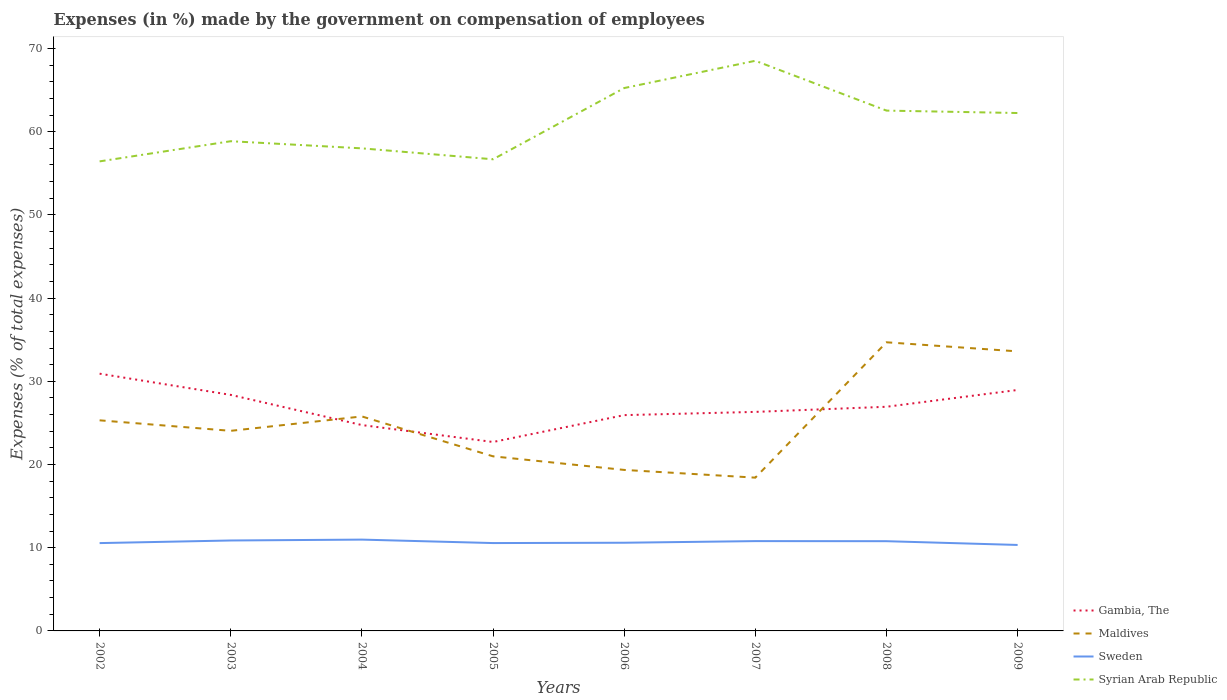Across all years, what is the maximum percentage of expenses made by the government on compensation of employees in Gambia, The?
Your answer should be compact. 22.71. What is the total percentage of expenses made by the government on compensation of employees in Sweden in the graph?
Provide a succinct answer. 0.27. What is the difference between the highest and the second highest percentage of expenses made by the government on compensation of employees in Gambia, The?
Your answer should be compact. 8.21. Is the percentage of expenses made by the government on compensation of employees in Gambia, The strictly greater than the percentage of expenses made by the government on compensation of employees in Maldives over the years?
Make the answer very short. No. How many years are there in the graph?
Give a very brief answer. 8. What is the difference between two consecutive major ticks on the Y-axis?
Your response must be concise. 10. Does the graph contain any zero values?
Keep it short and to the point. No. Does the graph contain grids?
Offer a very short reply. No. Where does the legend appear in the graph?
Your answer should be very brief. Bottom right. What is the title of the graph?
Provide a short and direct response. Expenses (in %) made by the government on compensation of employees. Does "Moldova" appear as one of the legend labels in the graph?
Offer a terse response. No. What is the label or title of the Y-axis?
Keep it short and to the point. Expenses (% of total expenses). What is the Expenses (% of total expenses) of Gambia, The in 2002?
Keep it short and to the point. 30.92. What is the Expenses (% of total expenses) in Maldives in 2002?
Keep it short and to the point. 25.31. What is the Expenses (% of total expenses) in Sweden in 2002?
Ensure brevity in your answer.  10.56. What is the Expenses (% of total expenses) of Syrian Arab Republic in 2002?
Ensure brevity in your answer.  56.43. What is the Expenses (% of total expenses) in Gambia, The in 2003?
Provide a succinct answer. 28.37. What is the Expenses (% of total expenses) in Maldives in 2003?
Make the answer very short. 24.05. What is the Expenses (% of total expenses) of Sweden in 2003?
Offer a very short reply. 10.87. What is the Expenses (% of total expenses) of Syrian Arab Republic in 2003?
Your answer should be very brief. 58.86. What is the Expenses (% of total expenses) in Gambia, The in 2004?
Provide a succinct answer. 24.74. What is the Expenses (% of total expenses) in Maldives in 2004?
Your response must be concise. 25.78. What is the Expenses (% of total expenses) of Sweden in 2004?
Offer a terse response. 10.97. What is the Expenses (% of total expenses) in Syrian Arab Republic in 2004?
Make the answer very short. 58. What is the Expenses (% of total expenses) of Gambia, The in 2005?
Provide a succinct answer. 22.71. What is the Expenses (% of total expenses) of Maldives in 2005?
Provide a succinct answer. 20.98. What is the Expenses (% of total expenses) in Sweden in 2005?
Ensure brevity in your answer.  10.56. What is the Expenses (% of total expenses) of Syrian Arab Republic in 2005?
Provide a succinct answer. 56.68. What is the Expenses (% of total expenses) of Gambia, The in 2006?
Offer a terse response. 25.94. What is the Expenses (% of total expenses) of Maldives in 2006?
Provide a succinct answer. 19.35. What is the Expenses (% of total expenses) of Sweden in 2006?
Your response must be concise. 10.6. What is the Expenses (% of total expenses) in Syrian Arab Republic in 2006?
Your answer should be compact. 65.25. What is the Expenses (% of total expenses) in Gambia, The in 2007?
Give a very brief answer. 26.32. What is the Expenses (% of total expenses) in Maldives in 2007?
Your answer should be compact. 18.42. What is the Expenses (% of total expenses) of Sweden in 2007?
Provide a short and direct response. 10.79. What is the Expenses (% of total expenses) of Syrian Arab Republic in 2007?
Your response must be concise. 68.52. What is the Expenses (% of total expenses) in Gambia, The in 2008?
Offer a very short reply. 26.94. What is the Expenses (% of total expenses) in Maldives in 2008?
Your answer should be compact. 34.69. What is the Expenses (% of total expenses) of Sweden in 2008?
Give a very brief answer. 10.78. What is the Expenses (% of total expenses) in Syrian Arab Republic in 2008?
Give a very brief answer. 62.53. What is the Expenses (% of total expenses) in Gambia, The in 2009?
Make the answer very short. 28.96. What is the Expenses (% of total expenses) of Maldives in 2009?
Give a very brief answer. 33.6. What is the Expenses (% of total expenses) of Sweden in 2009?
Your answer should be very brief. 10.33. What is the Expenses (% of total expenses) of Syrian Arab Republic in 2009?
Ensure brevity in your answer.  62.24. Across all years, what is the maximum Expenses (% of total expenses) in Gambia, The?
Offer a very short reply. 30.92. Across all years, what is the maximum Expenses (% of total expenses) of Maldives?
Provide a succinct answer. 34.69. Across all years, what is the maximum Expenses (% of total expenses) of Sweden?
Offer a terse response. 10.97. Across all years, what is the maximum Expenses (% of total expenses) of Syrian Arab Republic?
Offer a terse response. 68.52. Across all years, what is the minimum Expenses (% of total expenses) of Gambia, The?
Keep it short and to the point. 22.71. Across all years, what is the minimum Expenses (% of total expenses) of Maldives?
Provide a short and direct response. 18.42. Across all years, what is the minimum Expenses (% of total expenses) in Sweden?
Ensure brevity in your answer.  10.33. Across all years, what is the minimum Expenses (% of total expenses) in Syrian Arab Republic?
Keep it short and to the point. 56.43. What is the total Expenses (% of total expenses) in Gambia, The in the graph?
Offer a terse response. 214.89. What is the total Expenses (% of total expenses) in Maldives in the graph?
Ensure brevity in your answer.  202.18. What is the total Expenses (% of total expenses) in Sweden in the graph?
Your answer should be compact. 85.47. What is the total Expenses (% of total expenses) of Syrian Arab Republic in the graph?
Provide a short and direct response. 488.51. What is the difference between the Expenses (% of total expenses) in Gambia, The in 2002 and that in 2003?
Offer a terse response. 2.55. What is the difference between the Expenses (% of total expenses) in Maldives in 2002 and that in 2003?
Give a very brief answer. 1.26. What is the difference between the Expenses (% of total expenses) in Sweden in 2002 and that in 2003?
Provide a succinct answer. -0.31. What is the difference between the Expenses (% of total expenses) of Syrian Arab Republic in 2002 and that in 2003?
Provide a succinct answer. -2.42. What is the difference between the Expenses (% of total expenses) in Gambia, The in 2002 and that in 2004?
Offer a very short reply. 6.18. What is the difference between the Expenses (% of total expenses) of Maldives in 2002 and that in 2004?
Offer a very short reply. -0.47. What is the difference between the Expenses (% of total expenses) in Sweden in 2002 and that in 2004?
Offer a very short reply. -0.42. What is the difference between the Expenses (% of total expenses) in Syrian Arab Republic in 2002 and that in 2004?
Keep it short and to the point. -1.57. What is the difference between the Expenses (% of total expenses) in Gambia, The in 2002 and that in 2005?
Provide a short and direct response. 8.21. What is the difference between the Expenses (% of total expenses) of Maldives in 2002 and that in 2005?
Provide a succinct answer. 4.33. What is the difference between the Expenses (% of total expenses) in Sweden in 2002 and that in 2005?
Keep it short and to the point. -0. What is the difference between the Expenses (% of total expenses) in Syrian Arab Republic in 2002 and that in 2005?
Keep it short and to the point. -0.25. What is the difference between the Expenses (% of total expenses) in Gambia, The in 2002 and that in 2006?
Keep it short and to the point. 4.98. What is the difference between the Expenses (% of total expenses) in Maldives in 2002 and that in 2006?
Give a very brief answer. 5.96. What is the difference between the Expenses (% of total expenses) in Sweden in 2002 and that in 2006?
Your answer should be very brief. -0.04. What is the difference between the Expenses (% of total expenses) of Syrian Arab Republic in 2002 and that in 2006?
Give a very brief answer. -8.81. What is the difference between the Expenses (% of total expenses) of Gambia, The in 2002 and that in 2007?
Give a very brief answer. 4.59. What is the difference between the Expenses (% of total expenses) of Maldives in 2002 and that in 2007?
Your answer should be compact. 6.89. What is the difference between the Expenses (% of total expenses) in Sweden in 2002 and that in 2007?
Your answer should be compact. -0.24. What is the difference between the Expenses (% of total expenses) in Syrian Arab Republic in 2002 and that in 2007?
Ensure brevity in your answer.  -12.09. What is the difference between the Expenses (% of total expenses) in Gambia, The in 2002 and that in 2008?
Your answer should be compact. 3.98. What is the difference between the Expenses (% of total expenses) in Maldives in 2002 and that in 2008?
Your answer should be very brief. -9.38. What is the difference between the Expenses (% of total expenses) of Sweden in 2002 and that in 2008?
Your answer should be very brief. -0.23. What is the difference between the Expenses (% of total expenses) in Syrian Arab Republic in 2002 and that in 2008?
Provide a succinct answer. -6.1. What is the difference between the Expenses (% of total expenses) of Gambia, The in 2002 and that in 2009?
Provide a succinct answer. 1.96. What is the difference between the Expenses (% of total expenses) in Maldives in 2002 and that in 2009?
Your answer should be very brief. -8.29. What is the difference between the Expenses (% of total expenses) of Sweden in 2002 and that in 2009?
Provide a succinct answer. 0.22. What is the difference between the Expenses (% of total expenses) of Syrian Arab Republic in 2002 and that in 2009?
Keep it short and to the point. -5.81. What is the difference between the Expenses (% of total expenses) in Gambia, The in 2003 and that in 2004?
Make the answer very short. 3.63. What is the difference between the Expenses (% of total expenses) of Maldives in 2003 and that in 2004?
Provide a succinct answer. -1.73. What is the difference between the Expenses (% of total expenses) in Sweden in 2003 and that in 2004?
Give a very brief answer. -0.1. What is the difference between the Expenses (% of total expenses) of Syrian Arab Republic in 2003 and that in 2004?
Give a very brief answer. 0.86. What is the difference between the Expenses (% of total expenses) in Gambia, The in 2003 and that in 2005?
Your answer should be very brief. 5.66. What is the difference between the Expenses (% of total expenses) in Maldives in 2003 and that in 2005?
Give a very brief answer. 3.07. What is the difference between the Expenses (% of total expenses) in Sweden in 2003 and that in 2005?
Offer a very short reply. 0.31. What is the difference between the Expenses (% of total expenses) in Syrian Arab Republic in 2003 and that in 2005?
Your response must be concise. 2.17. What is the difference between the Expenses (% of total expenses) of Gambia, The in 2003 and that in 2006?
Your answer should be very brief. 2.43. What is the difference between the Expenses (% of total expenses) of Maldives in 2003 and that in 2006?
Your answer should be compact. 4.7. What is the difference between the Expenses (% of total expenses) of Sweden in 2003 and that in 2006?
Your response must be concise. 0.27. What is the difference between the Expenses (% of total expenses) of Syrian Arab Republic in 2003 and that in 2006?
Ensure brevity in your answer.  -6.39. What is the difference between the Expenses (% of total expenses) in Gambia, The in 2003 and that in 2007?
Make the answer very short. 2.04. What is the difference between the Expenses (% of total expenses) in Maldives in 2003 and that in 2007?
Your answer should be compact. 5.63. What is the difference between the Expenses (% of total expenses) of Sweden in 2003 and that in 2007?
Your answer should be compact. 0.08. What is the difference between the Expenses (% of total expenses) of Syrian Arab Republic in 2003 and that in 2007?
Your answer should be very brief. -9.67. What is the difference between the Expenses (% of total expenses) of Gambia, The in 2003 and that in 2008?
Make the answer very short. 1.43. What is the difference between the Expenses (% of total expenses) in Maldives in 2003 and that in 2008?
Your answer should be very brief. -10.64. What is the difference between the Expenses (% of total expenses) of Sweden in 2003 and that in 2008?
Your response must be concise. 0.09. What is the difference between the Expenses (% of total expenses) of Syrian Arab Republic in 2003 and that in 2008?
Your answer should be compact. -3.68. What is the difference between the Expenses (% of total expenses) in Gambia, The in 2003 and that in 2009?
Your answer should be very brief. -0.59. What is the difference between the Expenses (% of total expenses) of Maldives in 2003 and that in 2009?
Offer a terse response. -9.55. What is the difference between the Expenses (% of total expenses) in Sweden in 2003 and that in 2009?
Your answer should be very brief. 0.54. What is the difference between the Expenses (% of total expenses) of Syrian Arab Republic in 2003 and that in 2009?
Keep it short and to the point. -3.39. What is the difference between the Expenses (% of total expenses) in Gambia, The in 2004 and that in 2005?
Keep it short and to the point. 2.03. What is the difference between the Expenses (% of total expenses) in Maldives in 2004 and that in 2005?
Offer a very short reply. 4.79. What is the difference between the Expenses (% of total expenses) of Sweden in 2004 and that in 2005?
Offer a terse response. 0.42. What is the difference between the Expenses (% of total expenses) in Syrian Arab Republic in 2004 and that in 2005?
Your answer should be very brief. 1.31. What is the difference between the Expenses (% of total expenses) of Gambia, The in 2004 and that in 2006?
Keep it short and to the point. -1.19. What is the difference between the Expenses (% of total expenses) of Maldives in 2004 and that in 2006?
Keep it short and to the point. 6.43. What is the difference between the Expenses (% of total expenses) of Sweden in 2004 and that in 2006?
Your answer should be very brief. 0.38. What is the difference between the Expenses (% of total expenses) of Syrian Arab Republic in 2004 and that in 2006?
Your answer should be very brief. -7.25. What is the difference between the Expenses (% of total expenses) in Gambia, The in 2004 and that in 2007?
Keep it short and to the point. -1.58. What is the difference between the Expenses (% of total expenses) of Maldives in 2004 and that in 2007?
Offer a terse response. 7.36. What is the difference between the Expenses (% of total expenses) of Sweden in 2004 and that in 2007?
Offer a terse response. 0.18. What is the difference between the Expenses (% of total expenses) of Syrian Arab Republic in 2004 and that in 2007?
Give a very brief answer. -10.52. What is the difference between the Expenses (% of total expenses) in Gambia, The in 2004 and that in 2008?
Your answer should be very brief. -2.2. What is the difference between the Expenses (% of total expenses) in Maldives in 2004 and that in 2008?
Provide a succinct answer. -8.91. What is the difference between the Expenses (% of total expenses) in Sweden in 2004 and that in 2008?
Your response must be concise. 0.19. What is the difference between the Expenses (% of total expenses) in Syrian Arab Republic in 2004 and that in 2008?
Give a very brief answer. -4.54. What is the difference between the Expenses (% of total expenses) in Gambia, The in 2004 and that in 2009?
Provide a succinct answer. -4.22. What is the difference between the Expenses (% of total expenses) of Maldives in 2004 and that in 2009?
Your answer should be very brief. -7.82. What is the difference between the Expenses (% of total expenses) in Sweden in 2004 and that in 2009?
Your answer should be compact. 0.64. What is the difference between the Expenses (% of total expenses) in Syrian Arab Republic in 2004 and that in 2009?
Keep it short and to the point. -4.25. What is the difference between the Expenses (% of total expenses) in Gambia, The in 2005 and that in 2006?
Provide a succinct answer. -3.23. What is the difference between the Expenses (% of total expenses) in Maldives in 2005 and that in 2006?
Your answer should be very brief. 1.63. What is the difference between the Expenses (% of total expenses) in Sweden in 2005 and that in 2006?
Provide a short and direct response. -0.04. What is the difference between the Expenses (% of total expenses) in Syrian Arab Republic in 2005 and that in 2006?
Give a very brief answer. -8.56. What is the difference between the Expenses (% of total expenses) of Gambia, The in 2005 and that in 2007?
Ensure brevity in your answer.  -3.62. What is the difference between the Expenses (% of total expenses) of Maldives in 2005 and that in 2007?
Make the answer very short. 2.56. What is the difference between the Expenses (% of total expenses) of Sweden in 2005 and that in 2007?
Offer a very short reply. -0.23. What is the difference between the Expenses (% of total expenses) of Syrian Arab Republic in 2005 and that in 2007?
Make the answer very short. -11.84. What is the difference between the Expenses (% of total expenses) of Gambia, The in 2005 and that in 2008?
Provide a short and direct response. -4.23. What is the difference between the Expenses (% of total expenses) in Maldives in 2005 and that in 2008?
Give a very brief answer. -13.71. What is the difference between the Expenses (% of total expenses) in Sweden in 2005 and that in 2008?
Your answer should be very brief. -0.22. What is the difference between the Expenses (% of total expenses) in Syrian Arab Republic in 2005 and that in 2008?
Your answer should be very brief. -5.85. What is the difference between the Expenses (% of total expenses) of Gambia, The in 2005 and that in 2009?
Keep it short and to the point. -6.25. What is the difference between the Expenses (% of total expenses) in Maldives in 2005 and that in 2009?
Provide a succinct answer. -12.61. What is the difference between the Expenses (% of total expenses) in Sweden in 2005 and that in 2009?
Offer a terse response. 0.23. What is the difference between the Expenses (% of total expenses) in Syrian Arab Republic in 2005 and that in 2009?
Your response must be concise. -5.56. What is the difference between the Expenses (% of total expenses) in Gambia, The in 2006 and that in 2007?
Give a very brief answer. -0.39. What is the difference between the Expenses (% of total expenses) of Maldives in 2006 and that in 2007?
Give a very brief answer. 0.93. What is the difference between the Expenses (% of total expenses) of Sweden in 2006 and that in 2007?
Offer a terse response. -0.2. What is the difference between the Expenses (% of total expenses) of Syrian Arab Republic in 2006 and that in 2007?
Keep it short and to the point. -3.28. What is the difference between the Expenses (% of total expenses) in Gambia, The in 2006 and that in 2008?
Ensure brevity in your answer.  -1. What is the difference between the Expenses (% of total expenses) of Maldives in 2006 and that in 2008?
Your answer should be very brief. -15.34. What is the difference between the Expenses (% of total expenses) of Sweden in 2006 and that in 2008?
Give a very brief answer. -0.19. What is the difference between the Expenses (% of total expenses) of Syrian Arab Republic in 2006 and that in 2008?
Your answer should be compact. 2.71. What is the difference between the Expenses (% of total expenses) in Gambia, The in 2006 and that in 2009?
Your response must be concise. -3.02. What is the difference between the Expenses (% of total expenses) of Maldives in 2006 and that in 2009?
Your answer should be very brief. -14.25. What is the difference between the Expenses (% of total expenses) of Sweden in 2006 and that in 2009?
Give a very brief answer. 0.27. What is the difference between the Expenses (% of total expenses) of Syrian Arab Republic in 2006 and that in 2009?
Make the answer very short. 3. What is the difference between the Expenses (% of total expenses) of Gambia, The in 2007 and that in 2008?
Make the answer very short. -0.62. What is the difference between the Expenses (% of total expenses) in Maldives in 2007 and that in 2008?
Ensure brevity in your answer.  -16.27. What is the difference between the Expenses (% of total expenses) of Sweden in 2007 and that in 2008?
Your response must be concise. 0.01. What is the difference between the Expenses (% of total expenses) of Syrian Arab Republic in 2007 and that in 2008?
Give a very brief answer. 5.99. What is the difference between the Expenses (% of total expenses) in Gambia, The in 2007 and that in 2009?
Offer a terse response. -2.63. What is the difference between the Expenses (% of total expenses) of Maldives in 2007 and that in 2009?
Provide a short and direct response. -15.18. What is the difference between the Expenses (% of total expenses) of Sweden in 2007 and that in 2009?
Ensure brevity in your answer.  0.46. What is the difference between the Expenses (% of total expenses) of Syrian Arab Republic in 2007 and that in 2009?
Your answer should be compact. 6.28. What is the difference between the Expenses (% of total expenses) in Gambia, The in 2008 and that in 2009?
Your answer should be compact. -2.02. What is the difference between the Expenses (% of total expenses) of Maldives in 2008 and that in 2009?
Provide a short and direct response. 1.09. What is the difference between the Expenses (% of total expenses) of Sweden in 2008 and that in 2009?
Ensure brevity in your answer.  0.45. What is the difference between the Expenses (% of total expenses) of Syrian Arab Republic in 2008 and that in 2009?
Make the answer very short. 0.29. What is the difference between the Expenses (% of total expenses) of Gambia, The in 2002 and the Expenses (% of total expenses) of Maldives in 2003?
Keep it short and to the point. 6.87. What is the difference between the Expenses (% of total expenses) of Gambia, The in 2002 and the Expenses (% of total expenses) of Sweden in 2003?
Make the answer very short. 20.05. What is the difference between the Expenses (% of total expenses) in Gambia, The in 2002 and the Expenses (% of total expenses) in Syrian Arab Republic in 2003?
Keep it short and to the point. -27.94. What is the difference between the Expenses (% of total expenses) in Maldives in 2002 and the Expenses (% of total expenses) in Sweden in 2003?
Your answer should be compact. 14.44. What is the difference between the Expenses (% of total expenses) of Maldives in 2002 and the Expenses (% of total expenses) of Syrian Arab Republic in 2003?
Your answer should be very brief. -33.55. What is the difference between the Expenses (% of total expenses) in Sweden in 2002 and the Expenses (% of total expenses) in Syrian Arab Republic in 2003?
Provide a succinct answer. -48.3. What is the difference between the Expenses (% of total expenses) in Gambia, The in 2002 and the Expenses (% of total expenses) in Maldives in 2004?
Give a very brief answer. 5.14. What is the difference between the Expenses (% of total expenses) of Gambia, The in 2002 and the Expenses (% of total expenses) of Sweden in 2004?
Your response must be concise. 19.94. What is the difference between the Expenses (% of total expenses) of Gambia, The in 2002 and the Expenses (% of total expenses) of Syrian Arab Republic in 2004?
Keep it short and to the point. -27.08. What is the difference between the Expenses (% of total expenses) in Maldives in 2002 and the Expenses (% of total expenses) in Sweden in 2004?
Offer a very short reply. 14.34. What is the difference between the Expenses (% of total expenses) in Maldives in 2002 and the Expenses (% of total expenses) in Syrian Arab Republic in 2004?
Your response must be concise. -32.69. What is the difference between the Expenses (% of total expenses) of Sweden in 2002 and the Expenses (% of total expenses) of Syrian Arab Republic in 2004?
Ensure brevity in your answer.  -47.44. What is the difference between the Expenses (% of total expenses) in Gambia, The in 2002 and the Expenses (% of total expenses) in Maldives in 2005?
Provide a succinct answer. 9.93. What is the difference between the Expenses (% of total expenses) of Gambia, The in 2002 and the Expenses (% of total expenses) of Sweden in 2005?
Offer a terse response. 20.36. What is the difference between the Expenses (% of total expenses) in Gambia, The in 2002 and the Expenses (% of total expenses) in Syrian Arab Republic in 2005?
Provide a succinct answer. -25.77. What is the difference between the Expenses (% of total expenses) of Maldives in 2002 and the Expenses (% of total expenses) of Sweden in 2005?
Ensure brevity in your answer.  14.75. What is the difference between the Expenses (% of total expenses) in Maldives in 2002 and the Expenses (% of total expenses) in Syrian Arab Republic in 2005?
Offer a terse response. -31.37. What is the difference between the Expenses (% of total expenses) of Sweden in 2002 and the Expenses (% of total expenses) of Syrian Arab Republic in 2005?
Keep it short and to the point. -46.13. What is the difference between the Expenses (% of total expenses) in Gambia, The in 2002 and the Expenses (% of total expenses) in Maldives in 2006?
Your answer should be compact. 11.57. What is the difference between the Expenses (% of total expenses) of Gambia, The in 2002 and the Expenses (% of total expenses) of Sweden in 2006?
Ensure brevity in your answer.  20.32. What is the difference between the Expenses (% of total expenses) in Gambia, The in 2002 and the Expenses (% of total expenses) in Syrian Arab Republic in 2006?
Provide a succinct answer. -34.33. What is the difference between the Expenses (% of total expenses) in Maldives in 2002 and the Expenses (% of total expenses) in Sweden in 2006?
Your answer should be compact. 14.71. What is the difference between the Expenses (% of total expenses) in Maldives in 2002 and the Expenses (% of total expenses) in Syrian Arab Republic in 2006?
Provide a short and direct response. -39.93. What is the difference between the Expenses (% of total expenses) of Sweden in 2002 and the Expenses (% of total expenses) of Syrian Arab Republic in 2006?
Offer a very short reply. -54.69. What is the difference between the Expenses (% of total expenses) of Gambia, The in 2002 and the Expenses (% of total expenses) of Maldives in 2007?
Provide a short and direct response. 12.49. What is the difference between the Expenses (% of total expenses) of Gambia, The in 2002 and the Expenses (% of total expenses) of Sweden in 2007?
Make the answer very short. 20.12. What is the difference between the Expenses (% of total expenses) of Gambia, The in 2002 and the Expenses (% of total expenses) of Syrian Arab Republic in 2007?
Provide a succinct answer. -37.61. What is the difference between the Expenses (% of total expenses) in Maldives in 2002 and the Expenses (% of total expenses) in Sweden in 2007?
Give a very brief answer. 14.52. What is the difference between the Expenses (% of total expenses) of Maldives in 2002 and the Expenses (% of total expenses) of Syrian Arab Republic in 2007?
Provide a succinct answer. -43.21. What is the difference between the Expenses (% of total expenses) of Sweden in 2002 and the Expenses (% of total expenses) of Syrian Arab Republic in 2007?
Provide a short and direct response. -57.97. What is the difference between the Expenses (% of total expenses) of Gambia, The in 2002 and the Expenses (% of total expenses) of Maldives in 2008?
Keep it short and to the point. -3.77. What is the difference between the Expenses (% of total expenses) in Gambia, The in 2002 and the Expenses (% of total expenses) in Sweden in 2008?
Make the answer very short. 20.13. What is the difference between the Expenses (% of total expenses) of Gambia, The in 2002 and the Expenses (% of total expenses) of Syrian Arab Republic in 2008?
Ensure brevity in your answer.  -31.62. What is the difference between the Expenses (% of total expenses) of Maldives in 2002 and the Expenses (% of total expenses) of Sweden in 2008?
Ensure brevity in your answer.  14.53. What is the difference between the Expenses (% of total expenses) of Maldives in 2002 and the Expenses (% of total expenses) of Syrian Arab Republic in 2008?
Your answer should be very brief. -37.22. What is the difference between the Expenses (% of total expenses) of Sweden in 2002 and the Expenses (% of total expenses) of Syrian Arab Republic in 2008?
Your answer should be compact. -51.98. What is the difference between the Expenses (% of total expenses) in Gambia, The in 2002 and the Expenses (% of total expenses) in Maldives in 2009?
Provide a succinct answer. -2.68. What is the difference between the Expenses (% of total expenses) in Gambia, The in 2002 and the Expenses (% of total expenses) in Sweden in 2009?
Provide a short and direct response. 20.58. What is the difference between the Expenses (% of total expenses) of Gambia, The in 2002 and the Expenses (% of total expenses) of Syrian Arab Republic in 2009?
Provide a short and direct response. -31.33. What is the difference between the Expenses (% of total expenses) in Maldives in 2002 and the Expenses (% of total expenses) in Sweden in 2009?
Keep it short and to the point. 14.98. What is the difference between the Expenses (% of total expenses) in Maldives in 2002 and the Expenses (% of total expenses) in Syrian Arab Republic in 2009?
Your response must be concise. -36.93. What is the difference between the Expenses (% of total expenses) in Sweden in 2002 and the Expenses (% of total expenses) in Syrian Arab Republic in 2009?
Ensure brevity in your answer.  -51.69. What is the difference between the Expenses (% of total expenses) of Gambia, The in 2003 and the Expenses (% of total expenses) of Maldives in 2004?
Your answer should be compact. 2.59. What is the difference between the Expenses (% of total expenses) of Gambia, The in 2003 and the Expenses (% of total expenses) of Sweden in 2004?
Keep it short and to the point. 17.39. What is the difference between the Expenses (% of total expenses) of Gambia, The in 2003 and the Expenses (% of total expenses) of Syrian Arab Republic in 2004?
Your answer should be very brief. -29.63. What is the difference between the Expenses (% of total expenses) in Maldives in 2003 and the Expenses (% of total expenses) in Sweden in 2004?
Make the answer very short. 13.07. What is the difference between the Expenses (% of total expenses) in Maldives in 2003 and the Expenses (% of total expenses) in Syrian Arab Republic in 2004?
Your answer should be very brief. -33.95. What is the difference between the Expenses (% of total expenses) of Sweden in 2003 and the Expenses (% of total expenses) of Syrian Arab Republic in 2004?
Your answer should be compact. -47.13. What is the difference between the Expenses (% of total expenses) of Gambia, The in 2003 and the Expenses (% of total expenses) of Maldives in 2005?
Offer a very short reply. 7.38. What is the difference between the Expenses (% of total expenses) in Gambia, The in 2003 and the Expenses (% of total expenses) in Sweden in 2005?
Give a very brief answer. 17.81. What is the difference between the Expenses (% of total expenses) of Gambia, The in 2003 and the Expenses (% of total expenses) of Syrian Arab Republic in 2005?
Make the answer very short. -28.32. What is the difference between the Expenses (% of total expenses) in Maldives in 2003 and the Expenses (% of total expenses) in Sweden in 2005?
Give a very brief answer. 13.49. What is the difference between the Expenses (% of total expenses) of Maldives in 2003 and the Expenses (% of total expenses) of Syrian Arab Republic in 2005?
Offer a very short reply. -32.64. What is the difference between the Expenses (% of total expenses) of Sweden in 2003 and the Expenses (% of total expenses) of Syrian Arab Republic in 2005?
Offer a very short reply. -45.81. What is the difference between the Expenses (% of total expenses) in Gambia, The in 2003 and the Expenses (% of total expenses) in Maldives in 2006?
Keep it short and to the point. 9.02. What is the difference between the Expenses (% of total expenses) in Gambia, The in 2003 and the Expenses (% of total expenses) in Sweden in 2006?
Your answer should be compact. 17.77. What is the difference between the Expenses (% of total expenses) of Gambia, The in 2003 and the Expenses (% of total expenses) of Syrian Arab Republic in 2006?
Your answer should be very brief. -36.88. What is the difference between the Expenses (% of total expenses) of Maldives in 2003 and the Expenses (% of total expenses) of Sweden in 2006?
Keep it short and to the point. 13.45. What is the difference between the Expenses (% of total expenses) in Maldives in 2003 and the Expenses (% of total expenses) in Syrian Arab Republic in 2006?
Give a very brief answer. -41.2. What is the difference between the Expenses (% of total expenses) of Sweden in 2003 and the Expenses (% of total expenses) of Syrian Arab Republic in 2006?
Provide a succinct answer. -54.38. What is the difference between the Expenses (% of total expenses) of Gambia, The in 2003 and the Expenses (% of total expenses) of Maldives in 2007?
Give a very brief answer. 9.94. What is the difference between the Expenses (% of total expenses) of Gambia, The in 2003 and the Expenses (% of total expenses) of Sweden in 2007?
Make the answer very short. 17.57. What is the difference between the Expenses (% of total expenses) of Gambia, The in 2003 and the Expenses (% of total expenses) of Syrian Arab Republic in 2007?
Offer a terse response. -40.16. What is the difference between the Expenses (% of total expenses) in Maldives in 2003 and the Expenses (% of total expenses) in Sweden in 2007?
Ensure brevity in your answer.  13.25. What is the difference between the Expenses (% of total expenses) in Maldives in 2003 and the Expenses (% of total expenses) in Syrian Arab Republic in 2007?
Offer a very short reply. -44.47. What is the difference between the Expenses (% of total expenses) in Sweden in 2003 and the Expenses (% of total expenses) in Syrian Arab Republic in 2007?
Make the answer very short. -57.65. What is the difference between the Expenses (% of total expenses) of Gambia, The in 2003 and the Expenses (% of total expenses) of Maldives in 2008?
Ensure brevity in your answer.  -6.32. What is the difference between the Expenses (% of total expenses) in Gambia, The in 2003 and the Expenses (% of total expenses) in Sweden in 2008?
Make the answer very short. 17.58. What is the difference between the Expenses (% of total expenses) of Gambia, The in 2003 and the Expenses (% of total expenses) of Syrian Arab Republic in 2008?
Provide a short and direct response. -34.17. What is the difference between the Expenses (% of total expenses) of Maldives in 2003 and the Expenses (% of total expenses) of Sweden in 2008?
Give a very brief answer. 13.26. What is the difference between the Expenses (% of total expenses) of Maldives in 2003 and the Expenses (% of total expenses) of Syrian Arab Republic in 2008?
Provide a short and direct response. -38.49. What is the difference between the Expenses (% of total expenses) in Sweden in 2003 and the Expenses (% of total expenses) in Syrian Arab Republic in 2008?
Offer a terse response. -51.66. What is the difference between the Expenses (% of total expenses) in Gambia, The in 2003 and the Expenses (% of total expenses) in Maldives in 2009?
Offer a terse response. -5.23. What is the difference between the Expenses (% of total expenses) of Gambia, The in 2003 and the Expenses (% of total expenses) of Sweden in 2009?
Make the answer very short. 18.03. What is the difference between the Expenses (% of total expenses) in Gambia, The in 2003 and the Expenses (% of total expenses) in Syrian Arab Republic in 2009?
Your answer should be very brief. -33.88. What is the difference between the Expenses (% of total expenses) of Maldives in 2003 and the Expenses (% of total expenses) of Sweden in 2009?
Make the answer very short. 13.72. What is the difference between the Expenses (% of total expenses) of Maldives in 2003 and the Expenses (% of total expenses) of Syrian Arab Republic in 2009?
Offer a very short reply. -38.2. What is the difference between the Expenses (% of total expenses) in Sweden in 2003 and the Expenses (% of total expenses) in Syrian Arab Republic in 2009?
Give a very brief answer. -51.37. What is the difference between the Expenses (% of total expenses) in Gambia, The in 2004 and the Expenses (% of total expenses) in Maldives in 2005?
Provide a short and direct response. 3.76. What is the difference between the Expenses (% of total expenses) of Gambia, The in 2004 and the Expenses (% of total expenses) of Sweden in 2005?
Ensure brevity in your answer.  14.18. What is the difference between the Expenses (% of total expenses) in Gambia, The in 2004 and the Expenses (% of total expenses) in Syrian Arab Republic in 2005?
Make the answer very short. -31.94. What is the difference between the Expenses (% of total expenses) of Maldives in 2004 and the Expenses (% of total expenses) of Sweden in 2005?
Make the answer very short. 15.22. What is the difference between the Expenses (% of total expenses) of Maldives in 2004 and the Expenses (% of total expenses) of Syrian Arab Republic in 2005?
Keep it short and to the point. -30.91. What is the difference between the Expenses (% of total expenses) in Sweden in 2004 and the Expenses (% of total expenses) in Syrian Arab Republic in 2005?
Ensure brevity in your answer.  -45.71. What is the difference between the Expenses (% of total expenses) in Gambia, The in 2004 and the Expenses (% of total expenses) in Maldives in 2006?
Ensure brevity in your answer.  5.39. What is the difference between the Expenses (% of total expenses) of Gambia, The in 2004 and the Expenses (% of total expenses) of Sweden in 2006?
Provide a short and direct response. 14.14. What is the difference between the Expenses (% of total expenses) in Gambia, The in 2004 and the Expenses (% of total expenses) in Syrian Arab Republic in 2006?
Your answer should be compact. -40.5. What is the difference between the Expenses (% of total expenses) of Maldives in 2004 and the Expenses (% of total expenses) of Sweden in 2006?
Provide a succinct answer. 15.18. What is the difference between the Expenses (% of total expenses) in Maldives in 2004 and the Expenses (% of total expenses) in Syrian Arab Republic in 2006?
Give a very brief answer. -39.47. What is the difference between the Expenses (% of total expenses) in Sweden in 2004 and the Expenses (% of total expenses) in Syrian Arab Republic in 2006?
Your response must be concise. -54.27. What is the difference between the Expenses (% of total expenses) of Gambia, The in 2004 and the Expenses (% of total expenses) of Maldives in 2007?
Offer a very short reply. 6.32. What is the difference between the Expenses (% of total expenses) of Gambia, The in 2004 and the Expenses (% of total expenses) of Sweden in 2007?
Ensure brevity in your answer.  13.95. What is the difference between the Expenses (% of total expenses) in Gambia, The in 2004 and the Expenses (% of total expenses) in Syrian Arab Republic in 2007?
Your answer should be very brief. -43.78. What is the difference between the Expenses (% of total expenses) of Maldives in 2004 and the Expenses (% of total expenses) of Sweden in 2007?
Give a very brief answer. 14.98. What is the difference between the Expenses (% of total expenses) of Maldives in 2004 and the Expenses (% of total expenses) of Syrian Arab Republic in 2007?
Give a very brief answer. -42.74. What is the difference between the Expenses (% of total expenses) of Sweden in 2004 and the Expenses (% of total expenses) of Syrian Arab Republic in 2007?
Offer a very short reply. -57.55. What is the difference between the Expenses (% of total expenses) of Gambia, The in 2004 and the Expenses (% of total expenses) of Maldives in 2008?
Offer a terse response. -9.95. What is the difference between the Expenses (% of total expenses) in Gambia, The in 2004 and the Expenses (% of total expenses) in Sweden in 2008?
Ensure brevity in your answer.  13.96. What is the difference between the Expenses (% of total expenses) in Gambia, The in 2004 and the Expenses (% of total expenses) in Syrian Arab Republic in 2008?
Keep it short and to the point. -37.79. What is the difference between the Expenses (% of total expenses) of Maldives in 2004 and the Expenses (% of total expenses) of Sweden in 2008?
Provide a short and direct response. 14.99. What is the difference between the Expenses (% of total expenses) in Maldives in 2004 and the Expenses (% of total expenses) in Syrian Arab Republic in 2008?
Provide a succinct answer. -36.76. What is the difference between the Expenses (% of total expenses) of Sweden in 2004 and the Expenses (% of total expenses) of Syrian Arab Republic in 2008?
Ensure brevity in your answer.  -51.56. What is the difference between the Expenses (% of total expenses) of Gambia, The in 2004 and the Expenses (% of total expenses) of Maldives in 2009?
Ensure brevity in your answer.  -8.86. What is the difference between the Expenses (% of total expenses) in Gambia, The in 2004 and the Expenses (% of total expenses) in Sweden in 2009?
Give a very brief answer. 14.41. What is the difference between the Expenses (% of total expenses) of Gambia, The in 2004 and the Expenses (% of total expenses) of Syrian Arab Republic in 2009?
Offer a very short reply. -37.5. What is the difference between the Expenses (% of total expenses) in Maldives in 2004 and the Expenses (% of total expenses) in Sweden in 2009?
Make the answer very short. 15.44. What is the difference between the Expenses (% of total expenses) in Maldives in 2004 and the Expenses (% of total expenses) in Syrian Arab Republic in 2009?
Offer a very short reply. -36.47. What is the difference between the Expenses (% of total expenses) of Sweden in 2004 and the Expenses (% of total expenses) of Syrian Arab Republic in 2009?
Make the answer very short. -51.27. What is the difference between the Expenses (% of total expenses) in Gambia, The in 2005 and the Expenses (% of total expenses) in Maldives in 2006?
Make the answer very short. 3.36. What is the difference between the Expenses (% of total expenses) of Gambia, The in 2005 and the Expenses (% of total expenses) of Sweden in 2006?
Keep it short and to the point. 12.11. What is the difference between the Expenses (% of total expenses) in Gambia, The in 2005 and the Expenses (% of total expenses) in Syrian Arab Republic in 2006?
Give a very brief answer. -42.54. What is the difference between the Expenses (% of total expenses) of Maldives in 2005 and the Expenses (% of total expenses) of Sweden in 2006?
Offer a very short reply. 10.38. What is the difference between the Expenses (% of total expenses) in Maldives in 2005 and the Expenses (% of total expenses) in Syrian Arab Republic in 2006?
Offer a terse response. -44.26. What is the difference between the Expenses (% of total expenses) of Sweden in 2005 and the Expenses (% of total expenses) of Syrian Arab Republic in 2006?
Your response must be concise. -54.69. What is the difference between the Expenses (% of total expenses) in Gambia, The in 2005 and the Expenses (% of total expenses) in Maldives in 2007?
Ensure brevity in your answer.  4.29. What is the difference between the Expenses (% of total expenses) in Gambia, The in 2005 and the Expenses (% of total expenses) in Sweden in 2007?
Your response must be concise. 11.91. What is the difference between the Expenses (% of total expenses) of Gambia, The in 2005 and the Expenses (% of total expenses) of Syrian Arab Republic in 2007?
Your answer should be compact. -45.81. What is the difference between the Expenses (% of total expenses) in Maldives in 2005 and the Expenses (% of total expenses) in Sweden in 2007?
Provide a short and direct response. 10.19. What is the difference between the Expenses (% of total expenses) in Maldives in 2005 and the Expenses (% of total expenses) in Syrian Arab Republic in 2007?
Keep it short and to the point. -47.54. What is the difference between the Expenses (% of total expenses) of Sweden in 2005 and the Expenses (% of total expenses) of Syrian Arab Republic in 2007?
Your answer should be very brief. -57.96. What is the difference between the Expenses (% of total expenses) in Gambia, The in 2005 and the Expenses (% of total expenses) in Maldives in 2008?
Make the answer very short. -11.98. What is the difference between the Expenses (% of total expenses) in Gambia, The in 2005 and the Expenses (% of total expenses) in Sweden in 2008?
Give a very brief answer. 11.92. What is the difference between the Expenses (% of total expenses) in Gambia, The in 2005 and the Expenses (% of total expenses) in Syrian Arab Republic in 2008?
Your answer should be very brief. -39.83. What is the difference between the Expenses (% of total expenses) in Maldives in 2005 and the Expenses (% of total expenses) in Sweden in 2008?
Give a very brief answer. 10.2. What is the difference between the Expenses (% of total expenses) in Maldives in 2005 and the Expenses (% of total expenses) in Syrian Arab Republic in 2008?
Your answer should be compact. -41.55. What is the difference between the Expenses (% of total expenses) in Sweden in 2005 and the Expenses (% of total expenses) in Syrian Arab Republic in 2008?
Offer a very short reply. -51.97. What is the difference between the Expenses (% of total expenses) of Gambia, The in 2005 and the Expenses (% of total expenses) of Maldives in 2009?
Your response must be concise. -10.89. What is the difference between the Expenses (% of total expenses) of Gambia, The in 2005 and the Expenses (% of total expenses) of Sweden in 2009?
Your response must be concise. 12.37. What is the difference between the Expenses (% of total expenses) in Gambia, The in 2005 and the Expenses (% of total expenses) in Syrian Arab Republic in 2009?
Your response must be concise. -39.54. What is the difference between the Expenses (% of total expenses) of Maldives in 2005 and the Expenses (% of total expenses) of Sweden in 2009?
Keep it short and to the point. 10.65. What is the difference between the Expenses (% of total expenses) in Maldives in 2005 and the Expenses (% of total expenses) in Syrian Arab Republic in 2009?
Your answer should be very brief. -41.26. What is the difference between the Expenses (% of total expenses) in Sweden in 2005 and the Expenses (% of total expenses) in Syrian Arab Republic in 2009?
Make the answer very short. -51.68. What is the difference between the Expenses (% of total expenses) of Gambia, The in 2006 and the Expenses (% of total expenses) of Maldives in 2007?
Provide a short and direct response. 7.51. What is the difference between the Expenses (% of total expenses) in Gambia, The in 2006 and the Expenses (% of total expenses) in Sweden in 2007?
Provide a succinct answer. 15.14. What is the difference between the Expenses (% of total expenses) of Gambia, The in 2006 and the Expenses (% of total expenses) of Syrian Arab Republic in 2007?
Offer a terse response. -42.59. What is the difference between the Expenses (% of total expenses) in Maldives in 2006 and the Expenses (% of total expenses) in Sweden in 2007?
Offer a terse response. 8.56. What is the difference between the Expenses (% of total expenses) in Maldives in 2006 and the Expenses (% of total expenses) in Syrian Arab Republic in 2007?
Your answer should be very brief. -49.17. What is the difference between the Expenses (% of total expenses) of Sweden in 2006 and the Expenses (% of total expenses) of Syrian Arab Republic in 2007?
Keep it short and to the point. -57.92. What is the difference between the Expenses (% of total expenses) in Gambia, The in 2006 and the Expenses (% of total expenses) in Maldives in 2008?
Your response must be concise. -8.75. What is the difference between the Expenses (% of total expenses) in Gambia, The in 2006 and the Expenses (% of total expenses) in Sweden in 2008?
Your answer should be compact. 15.15. What is the difference between the Expenses (% of total expenses) of Gambia, The in 2006 and the Expenses (% of total expenses) of Syrian Arab Republic in 2008?
Your response must be concise. -36.6. What is the difference between the Expenses (% of total expenses) of Maldives in 2006 and the Expenses (% of total expenses) of Sweden in 2008?
Ensure brevity in your answer.  8.57. What is the difference between the Expenses (% of total expenses) of Maldives in 2006 and the Expenses (% of total expenses) of Syrian Arab Republic in 2008?
Your response must be concise. -43.18. What is the difference between the Expenses (% of total expenses) of Sweden in 2006 and the Expenses (% of total expenses) of Syrian Arab Republic in 2008?
Offer a very short reply. -51.94. What is the difference between the Expenses (% of total expenses) in Gambia, The in 2006 and the Expenses (% of total expenses) in Maldives in 2009?
Keep it short and to the point. -7.66. What is the difference between the Expenses (% of total expenses) of Gambia, The in 2006 and the Expenses (% of total expenses) of Sweden in 2009?
Make the answer very short. 15.6. What is the difference between the Expenses (% of total expenses) of Gambia, The in 2006 and the Expenses (% of total expenses) of Syrian Arab Republic in 2009?
Provide a short and direct response. -36.31. What is the difference between the Expenses (% of total expenses) of Maldives in 2006 and the Expenses (% of total expenses) of Sweden in 2009?
Keep it short and to the point. 9.02. What is the difference between the Expenses (% of total expenses) in Maldives in 2006 and the Expenses (% of total expenses) in Syrian Arab Republic in 2009?
Provide a succinct answer. -42.89. What is the difference between the Expenses (% of total expenses) of Sweden in 2006 and the Expenses (% of total expenses) of Syrian Arab Republic in 2009?
Your answer should be compact. -51.65. What is the difference between the Expenses (% of total expenses) in Gambia, The in 2007 and the Expenses (% of total expenses) in Maldives in 2008?
Provide a succinct answer. -8.36. What is the difference between the Expenses (% of total expenses) of Gambia, The in 2007 and the Expenses (% of total expenses) of Sweden in 2008?
Provide a short and direct response. 15.54. What is the difference between the Expenses (% of total expenses) in Gambia, The in 2007 and the Expenses (% of total expenses) in Syrian Arab Republic in 2008?
Your answer should be compact. -36.21. What is the difference between the Expenses (% of total expenses) in Maldives in 2007 and the Expenses (% of total expenses) in Sweden in 2008?
Make the answer very short. 7.64. What is the difference between the Expenses (% of total expenses) of Maldives in 2007 and the Expenses (% of total expenses) of Syrian Arab Republic in 2008?
Your answer should be very brief. -44.11. What is the difference between the Expenses (% of total expenses) in Sweden in 2007 and the Expenses (% of total expenses) in Syrian Arab Republic in 2008?
Your answer should be very brief. -51.74. What is the difference between the Expenses (% of total expenses) in Gambia, The in 2007 and the Expenses (% of total expenses) in Maldives in 2009?
Make the answer very short. -7.27. What is the difference between the Expenses (% of total expenses) in Gambia, The in 2007 and the Expenses (% of total expenses) in Sweden in 2009?
Ensure brevity in your answer.  15.99. What is the difference between the Expenses (% of total expenses) of Gambia, The in 2007 and the Expenses (% of total expenses) of Syrian Arab Republic in 2009?
Give a very brief answer. -35.92. What is the difference between the Expenses (% of total expenses) in Maldives in 2007 and the Expenses (% of total expenses) in Sweden in 2009?
Your response must be concise. 8.09. What is the difference between the Expenses (% of total expenses) of Maldives in 2007 and the Expenses (% of total expenses) of Syrian Arab Republic in 2009?
Your answer should be compact. -43.82. What is the difference between the Expenses (% of total expenses) in Sweden in 2007 and the Expenses (% of total expenses) in Syrian Arab Republic in 2009?
Offer a very short reply. -51.45. What is the difference between the Expenses (% of total expenses) in Gambia, The in 2008 and the Expenses (% of total expenses) in Maldives in 2009?
Make the answer very short. -6.66. What is the difference between the Expenses (% of total expenses) of Gambia, The in 2008 and the Expenses (% of total expenses) of Sweden in 2009?
Provide a short and direct response. 16.61. What is the difference between the Expenses (% of total expenses) in Gambia, The in 2008 and the Expenses (% of total expenses) in Syrian Arab Republic in 2009?
Provide a short and direct response. -35.3. What is the difference between the Expenses (% of total expenses) in Maldives in 2008 and the Expenses (% of total expenses) in Sweden in 2009?
Offer a very short reply. 24.36. What is the difference between the Expenses (% of total expenses) of Maldives in 2008 and the Expenses (% of total expenses) of Syrian Arab Republic in 2009?
Your response must be concise. -27.56. What is the difference between the Expenses (% of total expenses) in Sweden in 2008 and the Expenses (% of total expenses) in Syrian Arab Republic in 2009?
Your answer should be compact. -51.46. What is the average Expenses (% of total expenses) in Gambia, The per year?
Your answer should be compact. 26.86. What is the average Expenses (% of total expenses) of Maldives per year?
Give a very brief answer. 25.27. What is the average Expenses (% of total expenses) in Sweden per year?
Ensure brevity in your answer.  10.68. What is the average Expenses (% of total expenses) of Syrian Arab Republic per year?
Offer a terse response. 61.06. In the year 2002, what is the difference between the Expenses (% of total expenses) in Gambia, The and Expenses (% of total expenses) in Maldives?
Provide a short and direct response. 5.61. In the year 2002, what is the difference between the Expenses (% of total expenses) in Gambia, The and Expenses (% of total expenses) in Sweden?
Your response must be concise. 20.36. In the year 2002, what is the difference between the Expenses (% of total expenses) of Gambia, The and Expenses (% of total expenses) of Syrian Arab Republic?
Ensure brevity in your answer.  -25.52. In the year 2002, what is the difference between the Expenses (% of total expenses) of Maldives and Expenses (% of total expenses) of Sweden?
Keep it short and to the point. 14.75. In the year 2002, what is the difference between the Expenses (% of total expenses) in Maldives and Expenses (% of total expenses) in Syrian Arab Republic?
Your response must be concise. -31.12. In the year 2002, what is the difference between the Expenses (% of total expenses) of Sweden and Expenses (% of total expenses) of Syrian Arab Republic?
Give a very brief answer. -45.88. In the year 2003, what is the difference between the Expenses (% of total expenses) of Gambia, The and Expenses (% of total expenses) of Maldives?
Your response must be concise. 4.32. In the year 2003, what is the difference between the Expenses (% of total expenses) in Gambia, The and Expenses (% of total expenses) in Sweden?
Make the answer very short. 17.5. In the year 2003, what is the difference between the Expenses (% of total expenses) of Gambia, The and Expenses (% of total expenses) of Syrian Arab Republic?
Give a very brief answer. -30.49. In the year 2003, what is the difference between the Expenses (% of total expenses) in Maldives and Expenses (% of total expenses) in Sweden?
Ensure brevity in your answer.  13.18. In the year 2003, what is the difference between the Expenses (% of total expenses) of Maldives and Expenses (% of total expenses) of Syrian Arab Republic?
Make the answer very short. -34.81. In the year 2003, what is the difference between the Expenses (% of total expenses) of Sweden and Expenses (% of total expenses) of Syrian Arab Republic?
Your response must be concise. -47.99. In the year 2004, what is the difference between the Expenses (% of total expenses) of Gambia, The and Expenses (% of total expenses) of Maldives?
Keep it short and to the point. -1.04. In the year 2004, what is the difference between the Expenses (% of total expenses) of Gambia, The and Expenses (% of total expenses) of Sweden?
Your answer should be compact. 13.77. In the year 2004, what is the difference between the Expenses (% of total expenses) in Gambia, The and Expenses (% of total expenses) in Syrian Arab Republic?
Offer a very short reply. -33.26. In the year 2004, what is the difference between the Expenses (% of total expenses) in Maldives and Expenses (% of total expenses) in Sweden?
Provide a succinct answer. 14.8. In the year 2004, what is the difference between the Expenses (% of total expenses) of Maldives and Expenses (% of total expenses) of Syrian Arab Republic?
Give a very brief answer. -32.22. In the year 2004, what is the difference between the Expenses (% of total expenses) of Sweden and Expenses (% of total expenses) of Syrian Arab Republic?
Provide a succinct answer. -47.02. In the year 2005, what is the difference between the Expenses (% of total expenses) of Gambia, The and Expenses (% of total expenses) of Maldives?
Keep it short and to the point. 1.72. In the year 2005, what is the difference between the Expenses (% of total expenses) of Gambia, The and Expenses (% of total expenses) of Sweden?
Offer a very short reply. 12.15. In the year 2005, what is the difference between the Expenses (% of total expenses) of Gambia, The and Expenses (% of total expenses) of Syrian Arab Republic?
Keep it short and to the point. -33.98. In the year 2005, what is the difference between the Expenses (% of total expenses) in Maldives and Expenses (% of total expenses) in Sweden?
Offer a very short reply. 10.42. In the year 2005, what is the difference between the Expenses (% of total expenses) in Maldives and Expenses (% of total expenses) in Syrian Arab Republic?
Keep it short and to the point. -35.7. In the year 2005, what is the difference between the Expenses (% of total expenses) of Sweden and Expenses (% of total expenses) of Syrian Arab Republic?
Provide a succinct answer. -46.12. In the year 2006, what is the difference between the Expenses (% of total expenses) of Gambia, The and Expenses (% of total expenses) of Maldives?
Offer a terse response. 6.59. In the year 2006, what is the difference between the Expenses (% of total expenses) in Gambia, The and Expenses (% of total expenses) in Sweden?
Provide a short and direct response. 15.34. In the year 2006, what is the difference between the Expenses (% of total expenses) in Gambia, The and Expenses (% of total expenses) in Syrian Arab Republic?
Provide a short and direct response. -39.31. In the year 2006, what is the difference between the Expenses (% of total expenses) in Maldives and Expenses (% of total expenses) in Sweden?
Keep it short and to the point. 8.75. In the year 2006, what is the difference between the Expenses (% of total expenses) of Maldives and Expenses (% of total expenses) of Syrian Arab Republic?
Offer a very short reply. -45.9. In the year 2006, what is the difference between the Expenses (% of total expenses) of Sweden and Expenses (% of total expenses) of Syrian Arab Republic?
Your answer should be very brief. -54.65. In the year 2007, what is the difference between the Expenses (% of total expenses) of Gambia, The and Expenses (% of total expenses) of Maldives?
Ensure brevity in your answer.  7.9. In the year 2007, what is the difference between the Expenses (% of total expenses) of Gambia, The and Expenses (% of total expenses) of Sweden?
Make the answer very short. 15.53. In the year 2007, what is the difference between the Expenses (% of total expenses) of Gambia, The and Expenses (% of total expenses) of Syrian Arab Republic?
Offer a very short reply. -42.2. In the year 2007, what is the difference between the Expenses (% of total expenses) in Maldives and Expenses (% of total expenses) in Sweden?
Keep it short and to the point. 7.63. In the year 2007, what is the difference between the Expenses (% of total expenses) of Maldives and Expenses (% of total expenses) of Syrian Arab Republic?
Your response must be concise. -50.1. In the year 2007, what is the difference between the Expenses (% of total expenses) in Sweden and Expenses (% of total expenses) in Syrian Arab Republic?
Ensure brevity in your answer.  -57.73. In the year 2008, what is the difference between the Expenses (% of total expenses) in Gambia, The and Expenses (% of total expenses) in Maldives?
Provide a succinct answer. -7.75. In the year 2008, what is the difference between the Expenses (% of total expenses) of Gambia, The and Expenses (% of total expenses) of Sweden?
Ensure brevity in your answer.  16.16. In the year 2008, what is the difference between the Expenses (% of total expenses) in Gambia, The and Expenses (% of total expenses) in Syrian Arab Republic?
Provide a succinct answer. -35.59. In the year 2008, what is the difference between the Expenses (% of total expenses) in Maldives and Expenses (% of total expenses) in Sweden?
Your answer should be compact. 23.91. In the year 2008, what is the difference between the Expenses (% of total expenses) of Maldives and Expenses (% of total expenses) of Syrian Arab Republic?
Give a very brief answer. -27.85. In the year 2008, what is the difference between the Expenses (% of total expenses) in Sweden and Expenses (% of total expenses) in Syrian Arab Republic?
Provide a short and direct response. -51.75. In the year 2009, what is the difference between the Expenses (% of total expenses) of Gambia, The and Expenses (% of total expenses) of Maldives?
Make the answer very short. -4.64. In the year 2009, what is the difference between the Expenses (% of total expenses) of Gambia, The and Expenses (% of total expenses) of Sweden?
Provide a succinct answer. 18.63. In the year 2009, what is the difference between the Expenses (% of total expenses) of Gambia, The and Expenses (% of total expenses) of Syrian Arab Republic?
Offer a very short reply. -33.29. In the year 2009, what is the difference between the Expenses (% of total expenses) in Maldives and Expenses (% of total expenses) in Sweden?
Give a very brief answer. 23.27. In the year 2009, what is the difference between the Expenses (% of total expenses) of Maldives and Expenses (% of total expenses) of Syrian Arab Republic?
Offer a terse response. -28.65. In the year 2009, what is the difference between the Expenses (% of total expenses) of Sweden and Expenses (% of total expenses) of Syrian Arab Republic?
Your response must be concise. -51.91. What is the ratio of the Expenses (% of total expenses) in Gambia, The in 2002 to that in 2003?
Your answer should be compact. 1.09. What is the ratio of the Expenses (% of total expenses) of Maldives in 2002 to that in 2003?
Your response must be concise. 1.05. What is the ratio of the Expenses (% of total expenses) in Sweden in 2002 to that in 2003?
Make the answer very short. 0.97. What is the ratio of the Expenses (% of total expenses) in Syrian Arab Republic in 2002 to that in 2003?
Provide a short and direct response. 0.96. What is the ratio of the Expenses (% of total expenses) of Gambia, The in 2002 to that in 2004?
Provide a succinct answer. 1.25. What is the ratio of the Expenses (% of total expenses) in Maldives in 2002 to that in 2004?
Ensure brevity in your answer.  0.98. What is the ratio of the Expenses (% of total expenses) of Sweden in 2002 to that in 2004?
Offer a very short reply. 0.96. What is the ratio of the Expenses (% of total expenses) of Syrian Arab Republic in 2002 to that in 2004?
Make the answer very short. 0.97. What is the ratio of the Expenses (% of total expenses) of Gambia, The in 2002 to that in 2005?
Give a very brief answer. 1.36. What is the ratio of the Expenses (% of total expenses) of Maldives in 2002 to that in 2005?
Ensure brevity in your answer.  1.21. What is the ratio of the Expenses (% of total expenses) of Sweden in 2002 to that in 2005?
Provide a succinct answer. 1. What is the ratio of the Expenses (% of total expenses) of Syrian Arab Republic in 2002 to that in 2005?
Offer a very short reply. 1. What is the ratio of the Expenses (% of total expenses) in Gambia, The in 2002 to that in 2006?
Provide a short and direct response. 1.19. What is the ratio of the Expenses (% of total expenses) of Maldives in 2002 to that in 2006?
Offer a terse response. 1.31. What is the ratio of the Expenses (% of total expenses) of Syrian Arab Republic in 2002 to that in 2006?
Keep it short and to the point. 0.86. What is the ratio of the Expenses (% of total expenses) of Gambia, The in 2002 to that in 2007?
Provide a short and direct response. 1.17. What is the ratio of the Expenses (% of total expenses) in Maldives in 2002 to that in 2007?
Your answer should be compact. 1.37. What is the ratio of the Expenses (% of total expenses) in Sweden in 2002 to that in 2007?
Offer a terse response. 0.98. What is the ratio of the Expenses (% of total expenses) of Syrian Arab Republic in 2002 to that in 2007?
Give a very brief answer. 0.82. What is the ratio of the Expenses (% of total expenses) in Gambia, The in 2002 to that in 2008?
Your answer should be very brief. 1.15. What is the ratio of the Expenses (% of total expenses) in Maldives in 2002 to that in 2008?
Offer a very short reply. 0.73. What is the ratio of the Expenses (% of total expenses) in Sweden in 2002 to that in 2008?
Make the answer very short. 0.98. What is the ratio of the Expenses (% of total expenses) in Syrian Arab Republic in 2002 to that in 2008?
Keep it short and to the point. 0.9. What is the ratio of the Expenses (% of total expenses) of Gambia, The in 2002 to that in 2009?
Your answer should be very brief. 1.07. What is the ratio of the Expenses (% of total expenses) of Maldives in 2002 to that in 2009?
Provide a short and direct response. 0.75. What is the ratio of the Expenses (% of total expenses) of Sweden in 2002 to that in 2009?
Provide a succinct answer. 1.02. What is the ratio of the Expenses (% of total expenses) in Syrian Arab Republic in 2002 to that in 2009?
Your answer should be very brief. 0.91. What is the ratio of the Expenses (% of total expenses) in Gambia, The in 2003 to that in 2004?
Offer a very short reply. 1.15. What is the ratio of the Expenses (% of total expenses) of Maldives in 2003 to that in 2004?
Ensure brevity in your answer.  0.93. What is the ratio of the Expenses (% of total expenses) of Syrian Arab Republic in 2003 to that in 2004?
Ensure brevity in your answer.  1.01. What is the ratio of the Expenses (% of total expenses) of Gambia, The in 2003 to that in 2005?
Offer a very short reply. 1.25. What is the ratio of the Expenses (% of total expenses) in Maldives in 2003 to that in 2005?
Make the answer very short. 1.15. What is the ratio of the Expenses (% of total expenses) in Sweden in 2003 to that in 2005?
Your answer should be compact. 1.03. What is the ratio of the Expenses (% of total expenses) in Syrian Arab Republic in 2003 to that in 2005?
Your answer should be very brief. 1.04. What is the ratio of the Expenses (% of total expenses) in Gambia, The in 2003 to that in 2006?
Your answer should be compact. 1.09. What is the ratio of the Expenses (% of total expenses) in Maldives in 2003 to that in 2006?
Offer a terse response. 1.24. What is the ratio of the Expenses (% of total expenses) of Sweden in 2003 to that in 2006?
Offer a very short reply. 1.03. What is the ratio of the Expenses (% of total expenses) of Syrian Arab Republic in 2003 to that in 2006?
Give a very brief answer. 0.9. What is the ratio of the Expenses (% of total expenses) in Gambia, The in 2003 to that in 2007?
Offer a very short reply. 1.08. What is the ratio of the Expenses (% of total expenses) of Maldives in 2003 to that in 2007?
Your response must be concise. 1.31. What is the ratio of the Expenses (% of total expenses) of Syrian Arab Republic in 2003 to that in 2007?
Your answer should be compact. 0.86. What is the ratio of the Expenses (% of total expenses) of Gambia, The in 2003 to that in 2008?
Offer a terse response. 1.05. What is the ratio of the Expenses (% of total expenses) in Maldives in 2003 to that in 2008?
Your answer should be very brief. 0.69. What is the ratio of the Expenses (% of total expenses) of Sweden in 2003 to that in 2008?
Make the answer very short. 1.01. What is the ratio of the Expenses (% of total expenses) of Syrian Arab Republic in 2003 to that in 2008?
Offer a terse response. 0.94. What is the ratio of the Expenses (% of total expenses) in Gambia, The in 2003 to that in 2009?
Your answer should be compact. 0.98. What is the ratio of the Expenses (% of total expenses) of Maldives in 2003 to that in 2009?
Keep it short and to the point. 0.72. What is the ratio of the Expenses (% of total expenses) in Sweden in 2003 to that in 2009?
Your answer should be compact. 1.05. What is the ratio of the Expenses (% of total expenses) in Syrian Arab Republic in 2003 to that in 2009?
Your answer should be compact. 0.95. What is the ratio of the Expenses (% of total expenses) of Gambia, The in 2004 to that in 2005?
Keep it short and to the point. 1.09. What is the ratio of the Expenses (% of total expenses) in Maldives in 2004 to that in 2005?
Ensure brevity in your answer.  1.23. What is the ratio of the Expenses (% of total expenses) in Sweden in 2004 to that in 2005?
Offer a very short reply. 1.04. What is the ratio of the Expenses (% of total expenses) of Syrian Arab Republic in 2004 to that in 2005?
Your answer should be very brief. 1.02. What is the ratio of the Expenses (% of total expenses) in Gambia, The in 2004 to that in 2006?
Make the answer very short. 0.95. What is the ratio of the Expenses (% of total expenses) in Maldives in 2004 to that in 2006?
Offer a very short reply. 1.33. What is the ratio of the Expenses (% of total expenses) in Sweden in 2004 to that in 2006?
Your answer should be very brief. 1.04. What is the ratio of the Expenses (% of total expenses) of Gambia, The in 2004 to that in 2007?
Offer a very short reply. 0.94. What is the ratio of the Expenses (% of total expenses) of Maldives in 2004 to that in 2007?
Your answer should be very brief. 1.4. What is the ratio of the Expenses (% of total expenses) in Sweden in 2004 to that in 2007?
Keep it short and to the point. 1.02. What is the ratio of the Expenses (% of total expenses) of Syrian Arab Republic in 2004 to that in 2007?
Your answer should be compact. 0.85. What is the ratio of the Expenses (% of total expenses) in Gambia, The in 2004 to that in 2008?
Provide a short and direct response. 0.92. What is the ratio of the Expenses (% of total expenses) of Maldives in 2004 to that in 2008?
Provide a succinct answer. 0.74. What is the ratio of the Expenses (% of total expenses) of Sweden in 2004 to that in 2008?
Give a very brief answer. 1.02. What is the ratio of the Expenses (% of total expenses) in Syrian Arab Republic in 2004 to that in 2008?
Provide a short and direct response. 0.93. What is the ratio of the Expenses (% of total expenses) in Gambia, The in 2004 to that in 2009?
Your answer should be compact. 0.85. What is the ratio of the Expenses (% of total expenses) in Maldives in 2004 to that in 2009?
Provide a short and direct response. 0.77. What is the ratio of the Expenses (% of total expenses) in Sweden in 2004 to that in 2009?
Provide a short and direct response. 1.06. What is the ratio of the Expenses (% of total expenses) in Syrian Arab Republic in 2004 to that in 2009?
Give a very brief answer. 0.93. What is the ratio of the Expenses (% of total expenses) in Gambia, The in 2005 to that in 2006?
Provide a short and direct response. 0.88. What is the ratio of the Expenses (% of total expenses) of Maldives in 2005 to that in 2006?
Your answer should be compact. 1.08. What is the ratio of the Expenses (% of total expenses) in Syrian Arab Republic in 2005 to that in 2006?
Provide a succinct answer. 0.87. What is the ratio of the Expenses (% of total expenses) in Gambia, The in 2005 to that in 2007?
Your answer should be compact. 0.86. What is the ratio of the Expenses (% of total expenses) of Maldives in 2005 to that in 2007?
Your answer should be very brief. 1.14. What is the ratio of the Expenses (% of total expenses) in Sweden in 2005 to that in 2007?
Keep it short and to the point. 0.98. What is the ratio of the Expenses (% of total expenses) of Syrian Arab Republic in 2005 to that in 2007?
Provide a succinct answer. 0.83. What is the ratio of the Expenses (% of total expenses) of Gambia, The in 2005 to that in 2008?
Offer a terse response. 0.84. What is the ratio of the Expenses (% of total expenses) of Maldives in 2005 to that in 2008?
Ensure brevity in your answer.  0.6. What is the ratio of the Expenses (% of total expenses) of Sweden in 2005 to that in 2008?
Ensure brevity in your answer.  0.98. What is the ratio of the Expenses (% of total expenses) of Syrian Arab Republic in 2005 to that in 2008?
Your answer should be very brief. 0.91. What is the ratio of the Expenses (% of total expenses) of Gambia, The in 2005 to that in 2009?
Ensure brevity in your answer.  0.78. What is the ratio of the Expenses (% of total expenses) of Maldives in 2005 to that in 2009?
Your response must be concise. 0.62. What is the ratio of the Expenses (% of total expenses) of Sweden in 2005 to that in 2009?
Keep it short and to the point. 1.02. What is the ratio of the Expenses (% of total expenses) in Syrian Arab Republic in 2005 to that in 2009?
Provide a short and direct response. 0.91. What is the ratio of the Expenses (% of total expenses) of Gambia, The in 2006 to that in 2007?
Keep it short and to the point. 0.99. What is the ratio of the Expenses (% of total expenses) in Maldives in 2006 to that in 2007?
Ensure brevity in your answer.  1.05. What is the ratio of the Expenses (% of total expenses) of Sweden in 2006 to that in 2007?
Make the answer very short. 0.98. What is the ratio of the Expenses (% of total expenses) in Syrian Arab Republic in 2006 to that in 2007?
Keep it short and to the point. 0.95. What is the ratio of the Expenses (% of total expenses) in Gambia, The in 2006 to that in 2008?
Make the answer very short. 0.96. What is the ratio of the Expenses (% of total expenses) of Maldives in 2006 to that in 2008?
Keep it short and to the point. 0.56. What is the ratio of the Expenses (% of total expenses) of Sweden in 2006 to that in 2008?
Your response must be concise. 0.98. What is the ratio of the Expenses (% of total expenses) in Syrian Arab Republic in 2006 to that in 2008?
Offer a terse response. 1.04. What is the ratio of the Expenses (% of total expenses) in Gambia, The in 2006 to that in 2009?
Your answer should be compact. 0.9. What is the ratio of the Expenses (% of total expenses) in Maldives in 2006 to that in 2009?
Offer a terse response. 0.58. What is the ratio of the Expenses (% of total expenses) of Sweden in 2006 to that in 2009?
Your answer should be very brief. 1.03. What is the ratio of the Expenses (% of total expenses) in Syrian Arab Republic in 2006 to that in 2009?
Give a very brief answer. 1.05. What is the ratio of the Expenses (% of total expenses) in Gambia, The in 2007 to that in 2008?
Your answer should be compact. 0.98. What is the ratio of the Expenses (% of total expenses) in Maldives in 2007 to that in 2008?
Your answer should be compact. 0.53. What is the ratio of the Expenses (% of total expenses) in Syrian Arab Republic in 2007 to that in 2008?
Provide a succinct answer. 1.1. What is the ratio of the Expenses (% of total expenses) in Gambia, The in 2007 to that in 2009?
Offer a very short reply. 0.91. What is the ratio of the Expenses (% of total expenses) in Maldives in 2007 to that in 2009?
Provide a short and direct response. 0.55. What is the ratio of the Expenses (% of total expenses) in Sweden in 2007 to that in 2009?
Offer a very short reply. 1.04. What is the ratio of the Expenses (% of total expenses) of Syrian Arab Republic in 2007 to that in 2009?
Make the answer very short. 1.1. What is the ratio of the Expenses (% of total expenses) of Gambia, The in 2008 to that in 2009?
Keep it short and to the point. 0.93. What is the ratio of the Expenses (% of total expenses) in Maldives in 2008 to that in 2009?
Offer a terse response. 1.03. What is the ratio of the Expenses (% of total expenses) in Sweden in 2008 to that in 2009?
Your response must be concise. 1.04. What is the ratio of the Expenses (% of total expenses) of Syrian Arab Republic in 2008 to that in 2009?
Ensure brevity in your answer.  1. What is the difference between the highest and the second highest Expenses (% of total expenses) of Gambia, The?
Provide a short and direct response. 1.96. What is the difference between the highest and the second highest Expenses (% of total expenses) of Maldives?
Provide a succinct answer. 1.09. What is the difference between the highest and the second highest Expenses (% of total expenses) in Sweden?
Offer a very short reply. 0.1. What is the difference between the highest and the second highest Expenses (% of total expenses) of Syrian Arab Republic?
Make the answer very short. 3.28. What is the difference between the highest and the lowest Expenses (% of total expenses) of Gambia, The?
Give a very brief answer. 8.21. What is the difference between the highest and the lowest Expenses (% of total expenses) in Maldives?
Your answer should be compact. 16.27. What is the difference between the highest and the lowest Expenses (% of total expenses) of Sweden?
Offer a very short reply. 0.64. What is the difference between the highest and the lowest Expenses (% of total expenses) in Syrian Arab Republic?
Your answer should be very brief. 12.09. 